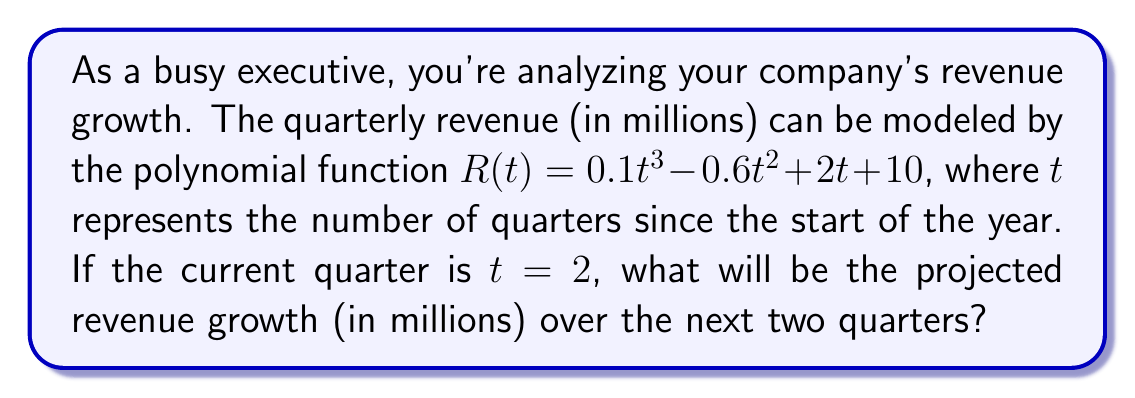Provide a solution to this math problem. To solve this problem, we need to follow these steps:

1. Calculate the revenue for the current quarter ($t=2$):
   $R(2) = 0.1(2^3) - 0.6(2^2) + 2(2) + 10$
   $R(2) = 0.1(8) - 0.6(4) + 4 + 10$
   $R(2) = 0.8 - 2.4 + 4 + 10 = 12.4$ million

2. Calculate the revenue for two quarters later ($t=4$):
   $R(4) = 0.1(4^3) - 0.6(4^2) + 2(4) + 10$
   $R(4) = 0.1(64) - 0.6(16) + 8 + 10$
   $R(4) = 6.4 - 9.6 + 8 + 10 = 14.8$ million

3. Calculate the revenue growth by subtracting the current revenue from the projected revenue:
   Growth = $R(4) - R(2) = 14.8 - 12.4 = 2.4$ million

Therefore, the projected revenue growth over the next two quarters is $2.4 million.
Answer: $2.4 million 